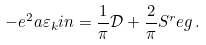<formula> <loc_0><loc_0><loc_500><loc_500>- e ^ { 2 } a \varepsilon _ { k } i n = \frac { 1 } { \pi } \mathcal { D } + \frac { 2 } { \pi } S ^ { r } e g \, .</formula> 